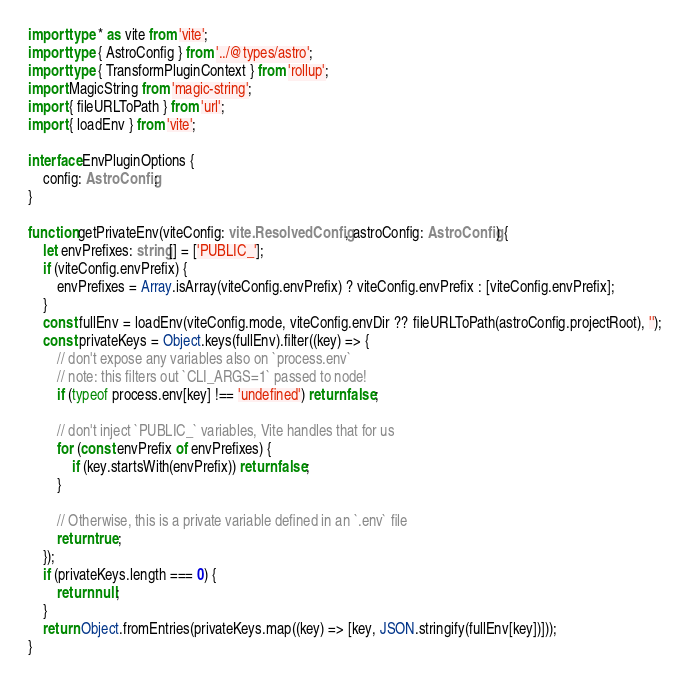Convert code to text. <code><loc_0><loc_0><loc_500><loc_500><_TypeScript_>import type * as vite from 'vite';
import type { AstroConfig } from '../@types/astro';
import type { TransformPluginContext } from 'rollup';
import MagicString from 'magic-string';
import { fileURLToPath } from 'url';
import { loadEnv } from 'vite';

interface EnvPluginOptions {
	config: AstroConfig;
}

function getPrivateEnv(viteConfig: vite.ResolvedConfig, astroConfig: AstroConfig) {
	let envPrefixes: string[] = ['PUBLIC_'];
	if (viteConfig.envPrefix) {
		envPrefixes = Array.isArray(viteConfig.envPrefix) ? viteConfig.envPrefix : [viteConfig.envPrefix];
	}
	const fullEnv = loadEnv(viteConfig.mode, viteConfig.envDir ?? fileURLToPath(astroConfig.projectRoot), '');
	const privateKeys = Object.keys(fullEnv).filter((key) => {
		// don't expose any variables also on `process.env`
		// note: this filters out `CLI_ARGS=1` passed to node!
		if (typeof process.env[key] !== 'undefined') return false;

		// don't inject `PUBLIC_` variables, Vite handles that for us
		for (const envPrefix of envPrefixes) {
			if (key.startsWith(envPrefix)) return false;
		}

		// Otherwise, this is a private variable defined in an `.env` file
		return true;
	});
	if (privateKeys.length === 0) {
		return null;
	}
	return Object.fromEntries(privateKeys.map((key) => [key, JSON.stringify(fullEnv[key])]));
}
</code> 